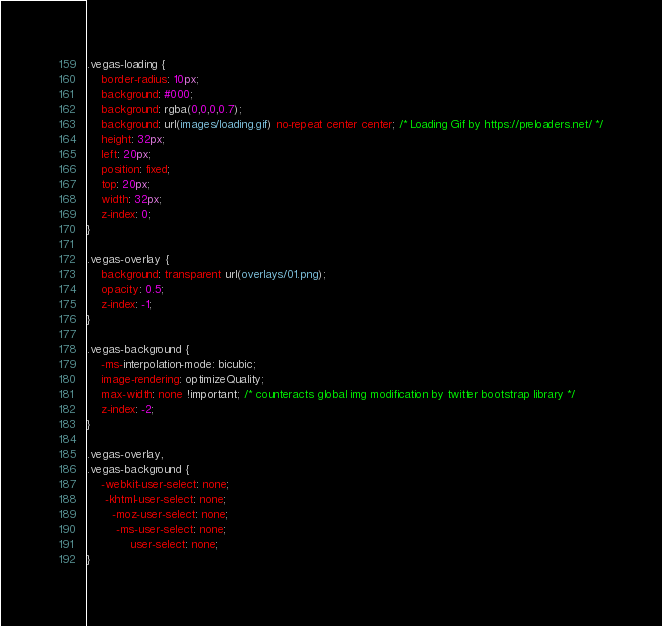<code> <loc_0><loc_0><loc_500><loc_500><_CSS_>.vegas-loading {
	border-radius: 10px;
	background: #000;
	background: rgba(0,0,0,0.7);
	background: url(images/loading.gif) no-repeat center center; /* Loading Gif by https://preloaders.net/ */
	height: 32px;
	left: 20px;
	position: fixed;
	top: 20px;
	width: 32px; 
	z-index: 0;
}

.vegas-overlay {
	background: transparent url(overlays/01.png);
	opacity: 0.5;
	z-index: -1;
}

.vegas-background {
	-ms-interpolation-mode: bicubic;
	image-rendering: optimizeQuality;
    max-width: none !important; /* counteracts global img modification by twitter bootstrap library */
	z-index: -2;
}

.vegas-overlay,
.vegas-background {
	-webkit-user-select: none;
	 -khtml-user-select: none;
	   -moz-user-select: none;
	    -ms-user-select: none;
	        user-select: none;
}</code> 